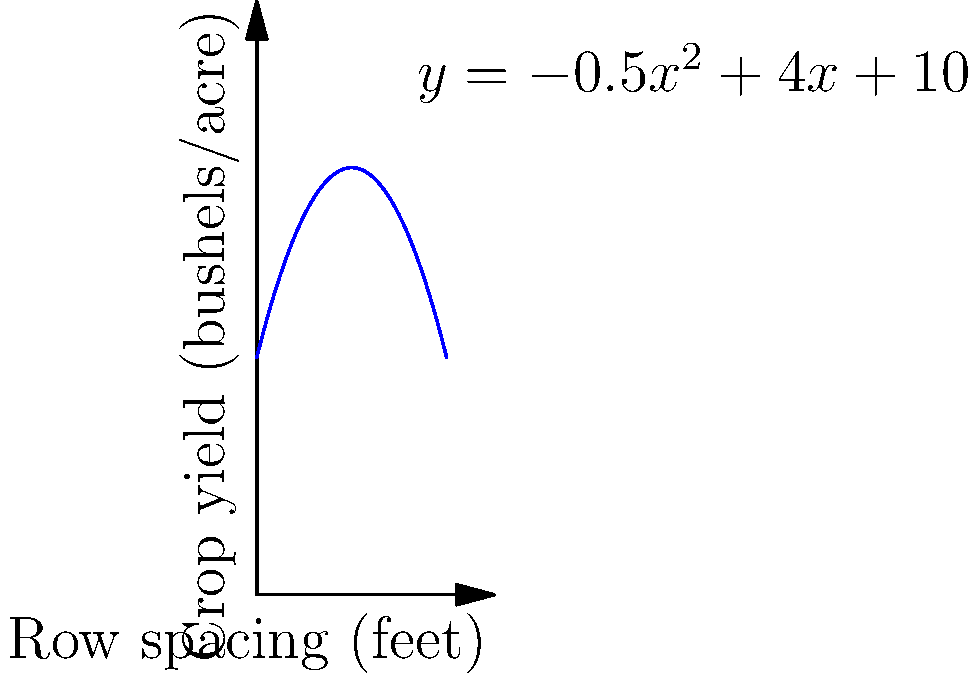As a community leader promoting sustainable farming practices, you're advising local farmers on optimal crop spacing. The relationship between row spacing and crop yield for a particular crop is modeled by the function $y = -0.5x^2 + 4x + 10$, where $y$ is the crop yield in bushels per acre and $x$ is the row spacing in feet. What row spacing will maximize the crop yield, and what is the maximum yield? To find the optimal row spacing and maximum yield, we need to follow these steps:

1) The function $y = -0.5x^2 + 4x + 10$ is a quadratic function, and its graph is a parabola that opens downward (because the coefficient of $x^2$ is negative).

2) The maximum point of a parabola occurs at the vertex. For a quadratic function in the form $f(x) = ax^2 + bx + c$, the x-coordinate of the vertex is given by $x = -\frac{b}{2a}$.

3) In our case, $a = -0.5$, $b = 4$, and $c = 10$. Let's calculate the x-coordinate of the vertex:

   $x = -\frac{b}{2a} = -\frac{4}{2(-0.5)} = -\frac{4}{-1} = 4$

4) This means the optimal row spacing is 4 feet.

5) To find the maximum yield, we need to calculate $y$ when $x = 4$:

   $y = -0.5(4)^2 + 4(4) + 10$
   $= -0.5(16) + 16 + 10$
   $= -8 + 16 + 10$
   $= 18$

Therefore, the maximum yield is 18 bushels per acre.
Answer: Optimal spacing: 4 feet; Maximum yield: 18 bushels/acre 